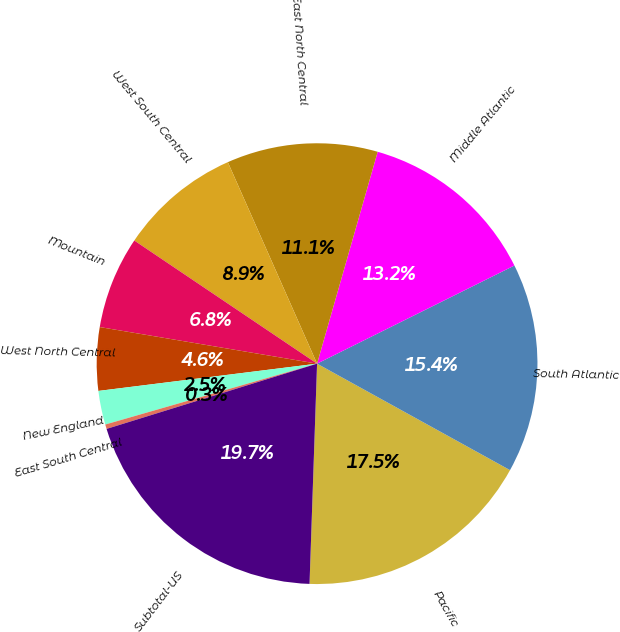Convert chart. <chart><loc_0><loc_0><loc_500><loc_500><pie_chart><fcel>Pacific<fcel>South Atlantic<fcel>Middle Atlantic<fcel>East North Central<fcel>West South Central<fcel>Mountain<fcel>West North Central<fcel>New England<fcel>East South Central<fcel>Subtotal-US<nl><fcel>17.52%<fcel>15.37%<fcel>13.22%<fcel>11.07%<fcel>8.93%<fcel>6.78%<fcel>4.63%<fcel>2.48%<fcel>0.33%<fcel>19.67%<nl></chart> 